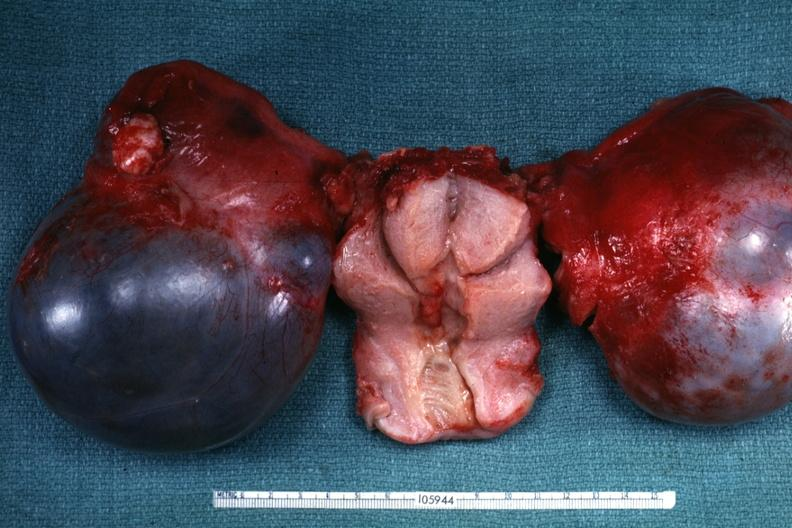what is not obvious from gross appearance?
Answer the question using a single word or phrase. Cystadenocarcinoma malignancy 